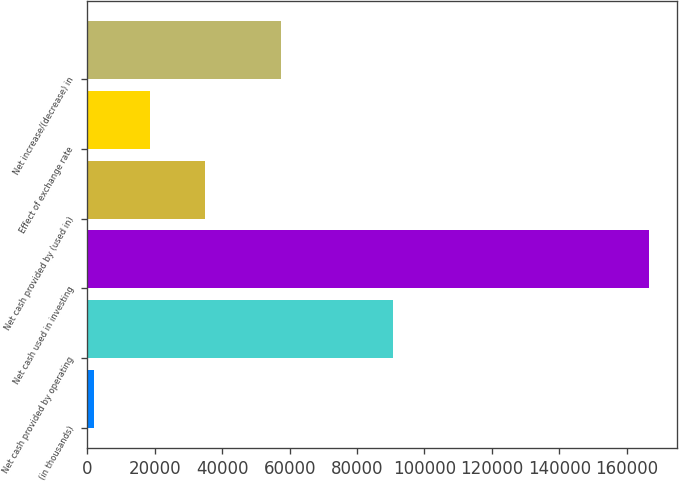Convert chart. <chart><loc_0><loc_0><loc_500><loc_500><bar_chart><fcel>(in thousands)<fcel>Net cash provided by operating<fcel>Net cash used in investing<fcel>Net cash provided by (used in)<fcel>Effect of exchange rate<fcel>Net increase/(decrease) in<nl><fcel>2008<fcel>90744<fcel>166717<fcel>34949.8<fcel>18478.9<fcel>57564<nl></chart> 